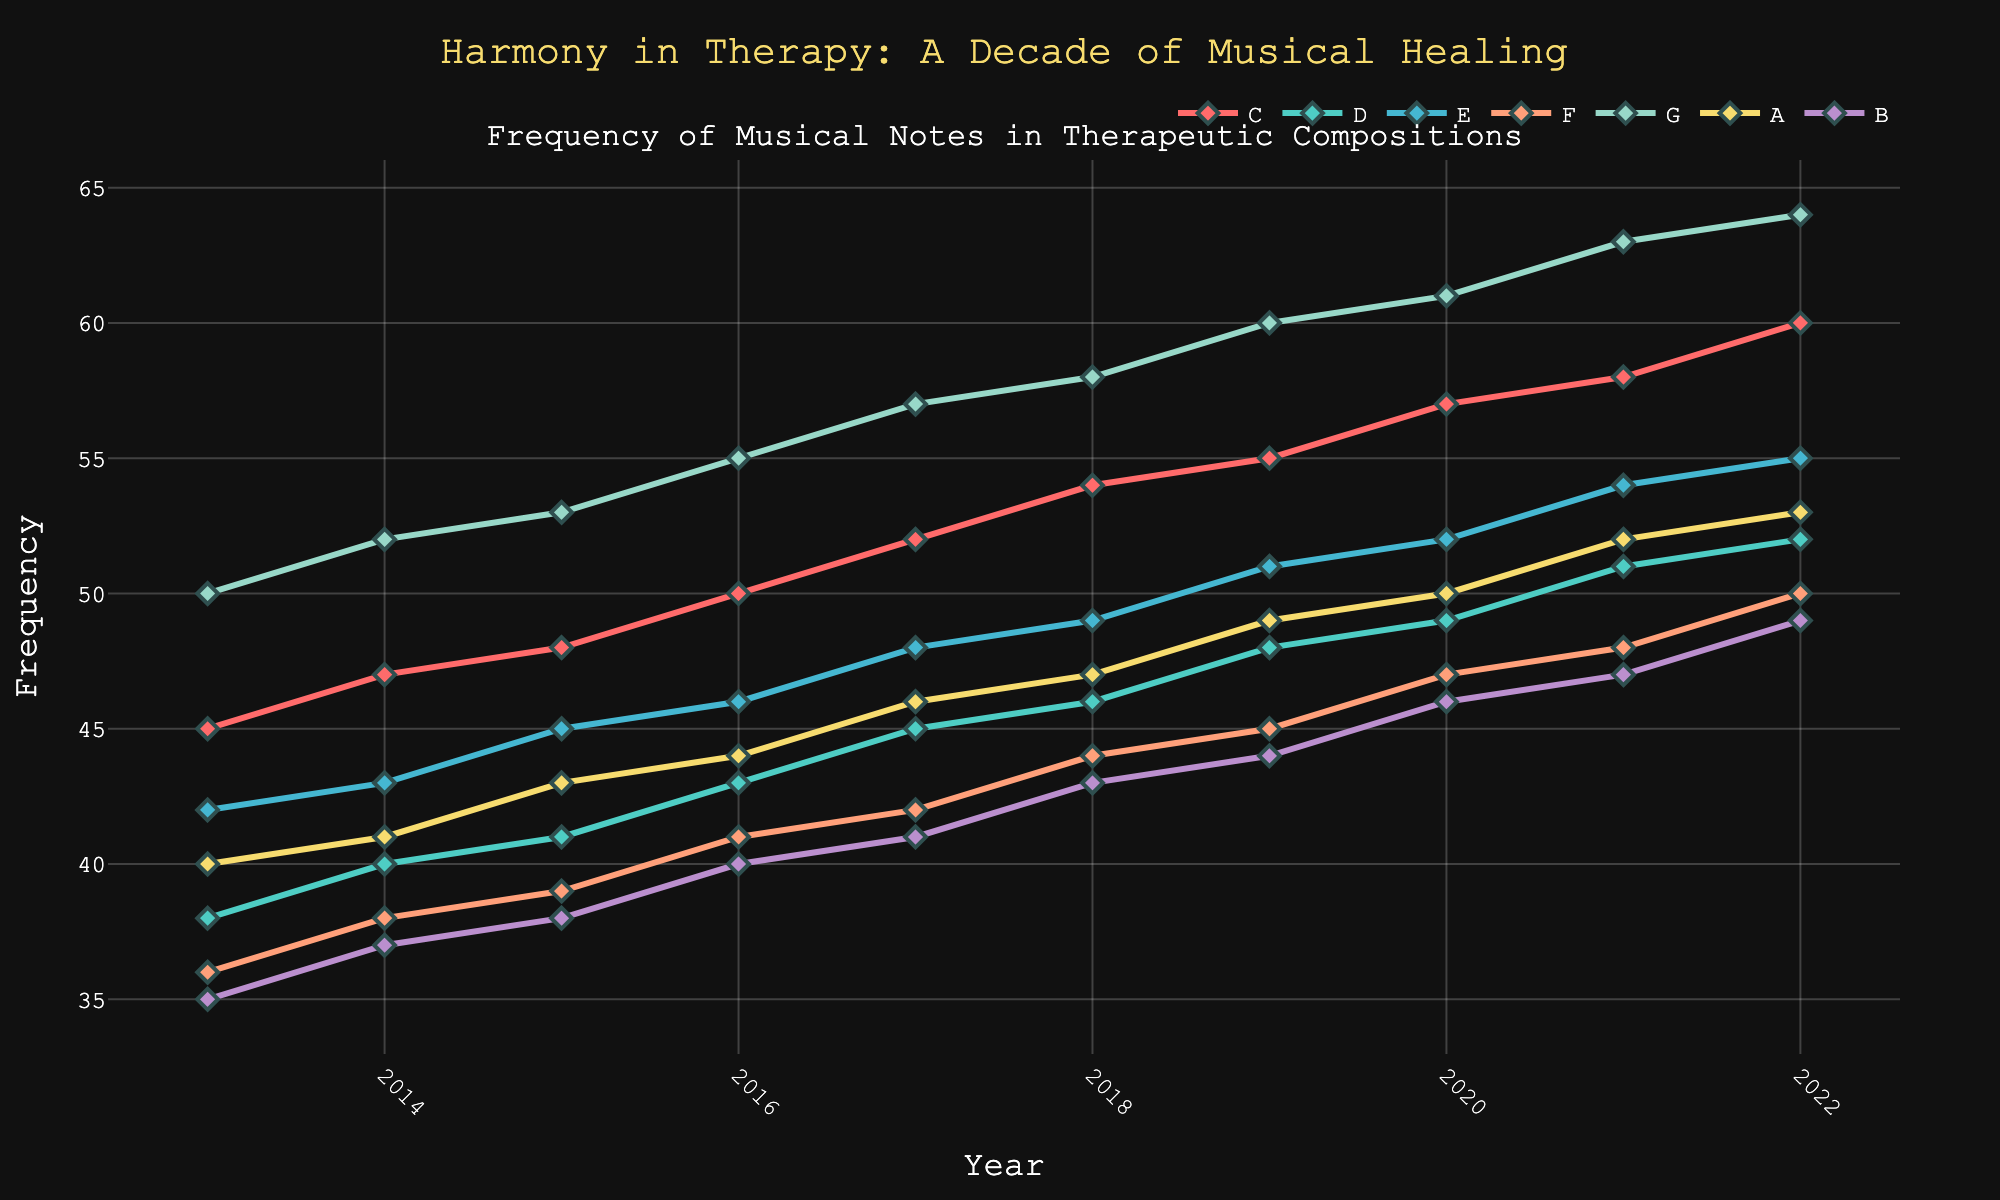What was the frequency of the note F in the year 2018? The line for note F intersects the year 2018 at a specific point. Looking directly at this intersection, we find the value on the y-axis.
Answer: 44 Which note showed the greatest frequency increase over the decade? By individually assessing the difference between the 2022 and 2013 data points for each note, we calculate the increases: C (+15), D (+14), E (+13), F (+14), G (+14), A (+13), B (+14). The note with the highest change is C with +15.
Answer: C What is the average frequency of note G from 2013 to 2022? Adding the frequencies for note G from each year: 50 + 52 + 53 + 55 + 57 + 58 + 60 + 61 + 63 + 64 = 573. Dividing this sum by 10 (number of years) gives 573/10 = 57.3.
Answer: 57.3 Between which two consecutive years did the note A have the highest increase in frequency? Observing the increments year-over-year: 2013-2014 (+1), 2014-2015 (+2), 2015-2016 (+1), 2016-2017 (+2), 2017-2018 (+1), 2018-2019 (+2), 2019-2020 (+1), 2020-2021 (+2), 2021-2022 (+1). The highest increase is between 2019 and 2020 (2 units).
Answer: 2019-2020 Which note was used the least frequently in 2021? Evaluating the frequencies in 2021 for all notes: C (58), D (51), E (54), F (48), G (63), A (52), B (47). The least frequent note in 2021 is B with a frequency of 47.
Answer: B 